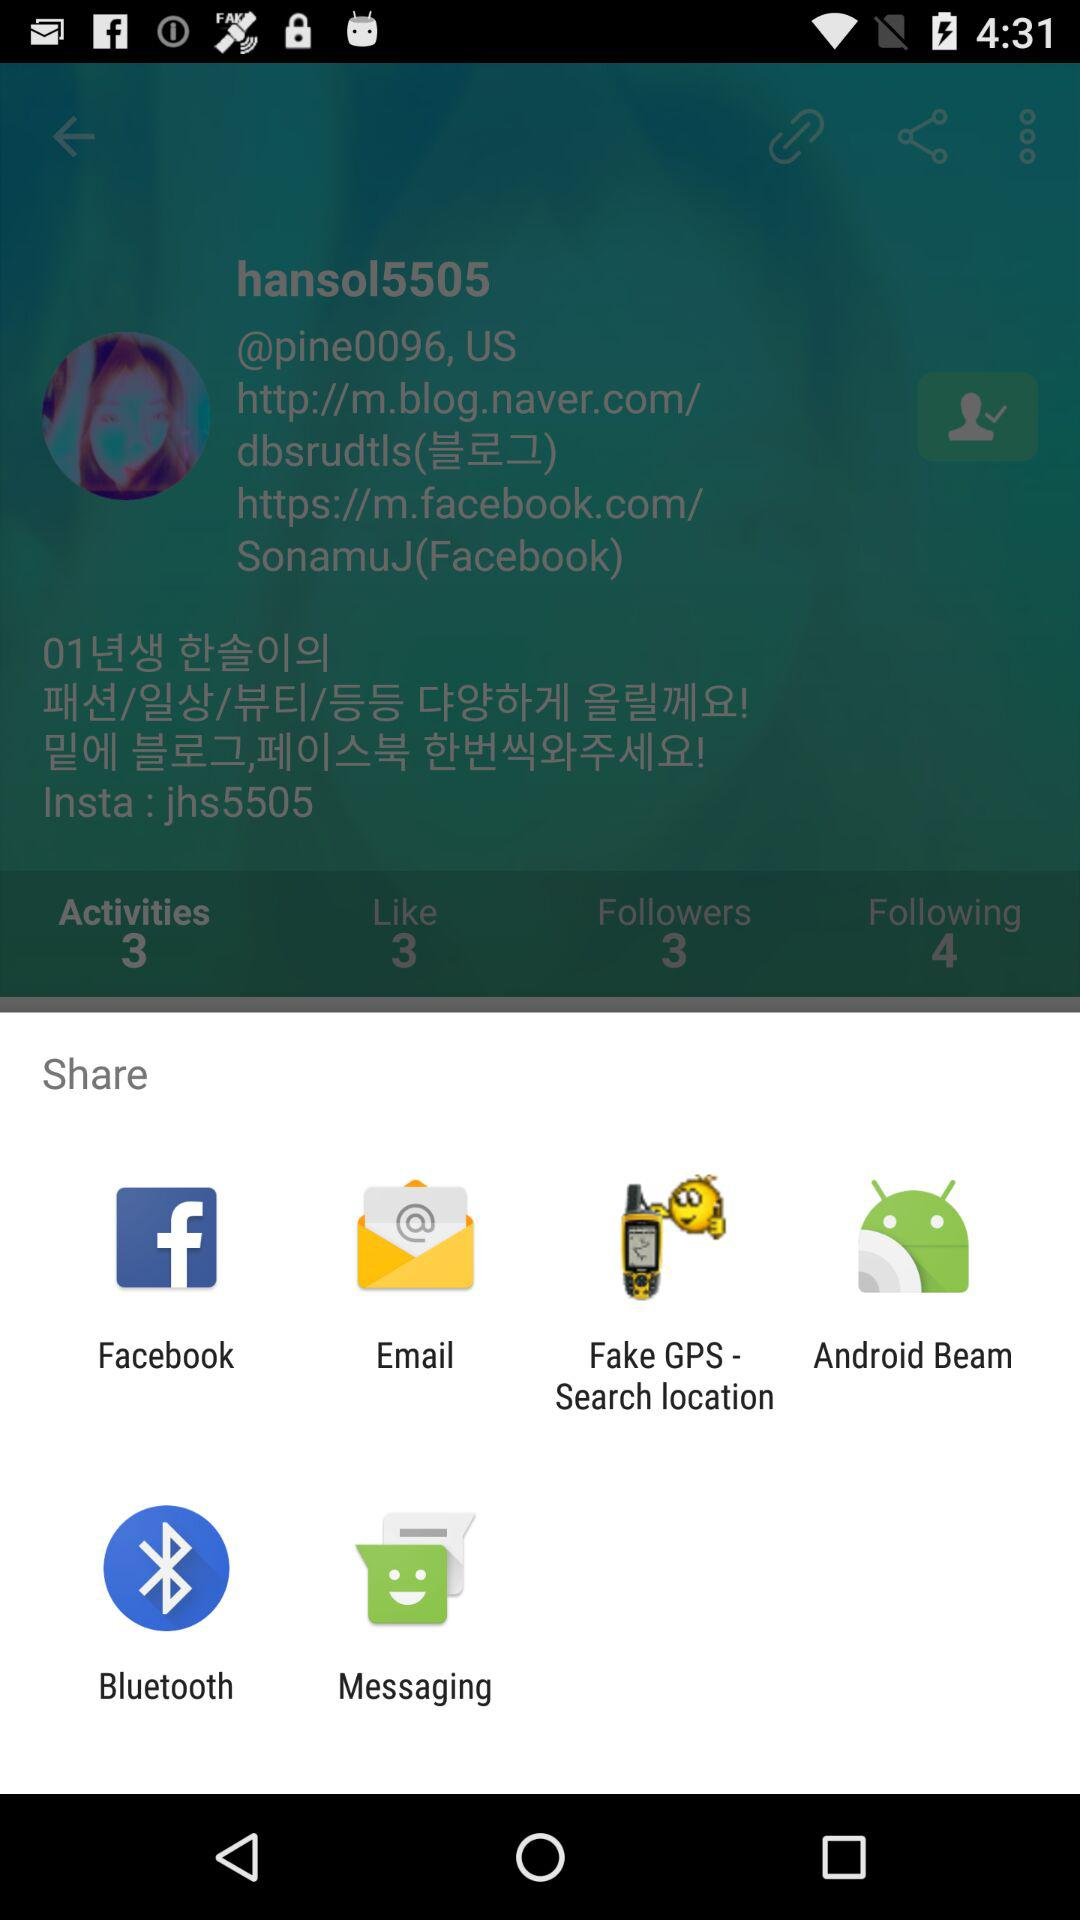What is the given location? The given location is "US". 